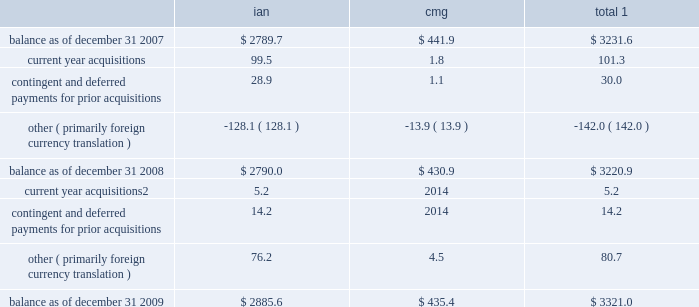Notes to consolidated financial statements 2014 ( continued ) ( amounts in millions , except per share amounts ) sales of businesses and investments 2013 primarily includes realized gains and losses relating to the sales of businesses , cumulative translation adjustment balances from the liquidation of entities and sales of marketable securities and investments in publicly traded and privately held companies in our rabbi trusts .
During 2009 , we realized a gain of $ 15.2 related to the sale of an investment in our rabbi trusts , which was partially offset by losses realized from the sale of various businesses .
Losses in 2007 primarily related to the sale of several businesses within draftfcb for a loss of $ 9.3 and charges at lowe of $ 7.8 as a result of the realization of cumulative translation adjustment balances from the liquidation of several businesses .
Vendor discounts and credit adjustments 2013 we are in the process of settling our liabilities related to vendor discounts and credits established during the restatement we presented in our 2004 annual report on form 10-k .
These adjustments reflect the reversal of certain of these liabilities as a result of settlements with clients or vendors or where the statute of limitations has lapsed .
Litigation settlement 2013 during may 2008 , the sec concluded its investigation that began in 2002 into our financial reporting practices , resulting in a settlement charge of $ 12.0 .
Investment impairments 2013 in 2007 we realized an other-than-temporary charge of $ 5.8 relating to a $ 12.5 investment in auction rate securities , representing our total investment in auction rate securities .
See note 12 for further information .
Note 5 : intangible assets goodwill goodwill is the excess purchase price remaining from an acquisition after an allocation of purchase price has been made to identifiable assets acquired and liabilities assumed based on estimated fair values .
The changes in the carrying value of goodwill for our segments , integrated agency networks ( 201cian 201d ) and constituency management group ( 201ccmg 201d ) , for the years ended december 31 , 2009 and 2008 are listed below. .
1 for all periods presented we have not recorded a goodwill impairment charge .
2 for acquisitions completed after january 1 , 2009 , amount includes contingent and deferred payments , which are recorded at fair value on the acquisition date .
See note 6 for further information .
See note 1 for further information regarding our annual impairment methodology .
Other intangible assets included in other intangible assets are assets with indefinite lives not subject to amortization and assets with definite lives subject to amortization .
Other intangible assets primarily include customer lists and trade names .
Intangible assets with definitive lives subject to amortization are amortized on a straight-line basis with estimated useful lives generally between 7 and 15 years .
Amortization expense for other intangible assets for the years ended december 31 , 2009 , 2008 and 2007 was $ 19.3 , $ 14.4 and $ 8.5 , respectively .
The following table provides a summary of other intangible assets , which are included in other assets on our consolidated balance sheets. .
What was the average amortization expense for other intangible assets for 2007-2009 , in millions? 
Computations: (((19.3 + 14.4) + 8.5) / 3)
Answer: 14.06667. 